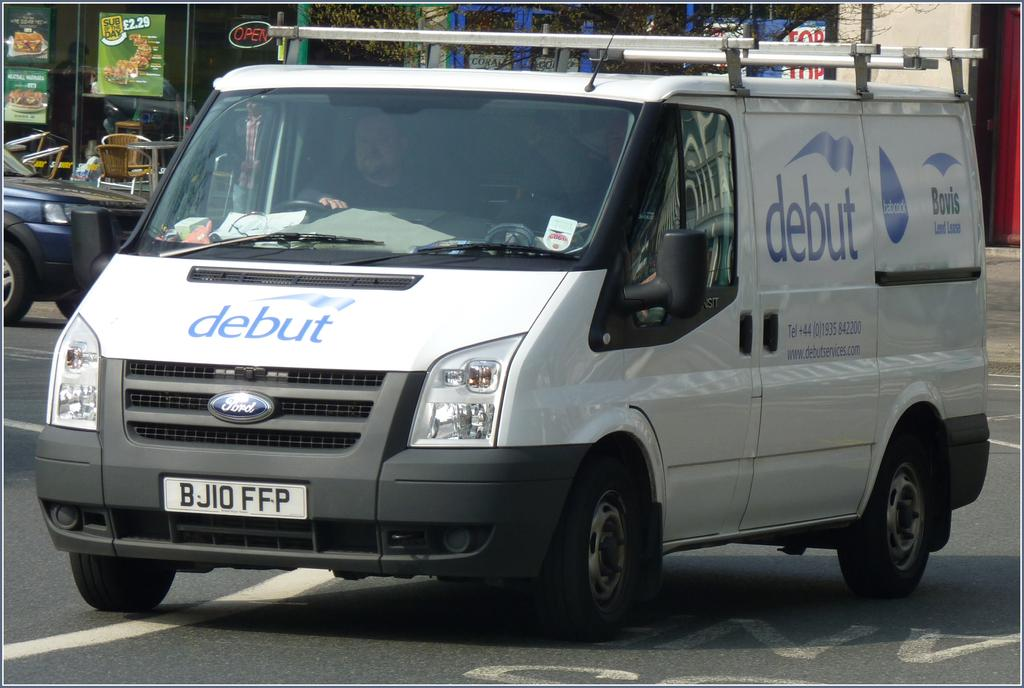<image>
Offer a succinct explanation of the picture presented. The white van belongs to Debut Services and provides phone number and website information for the company. 